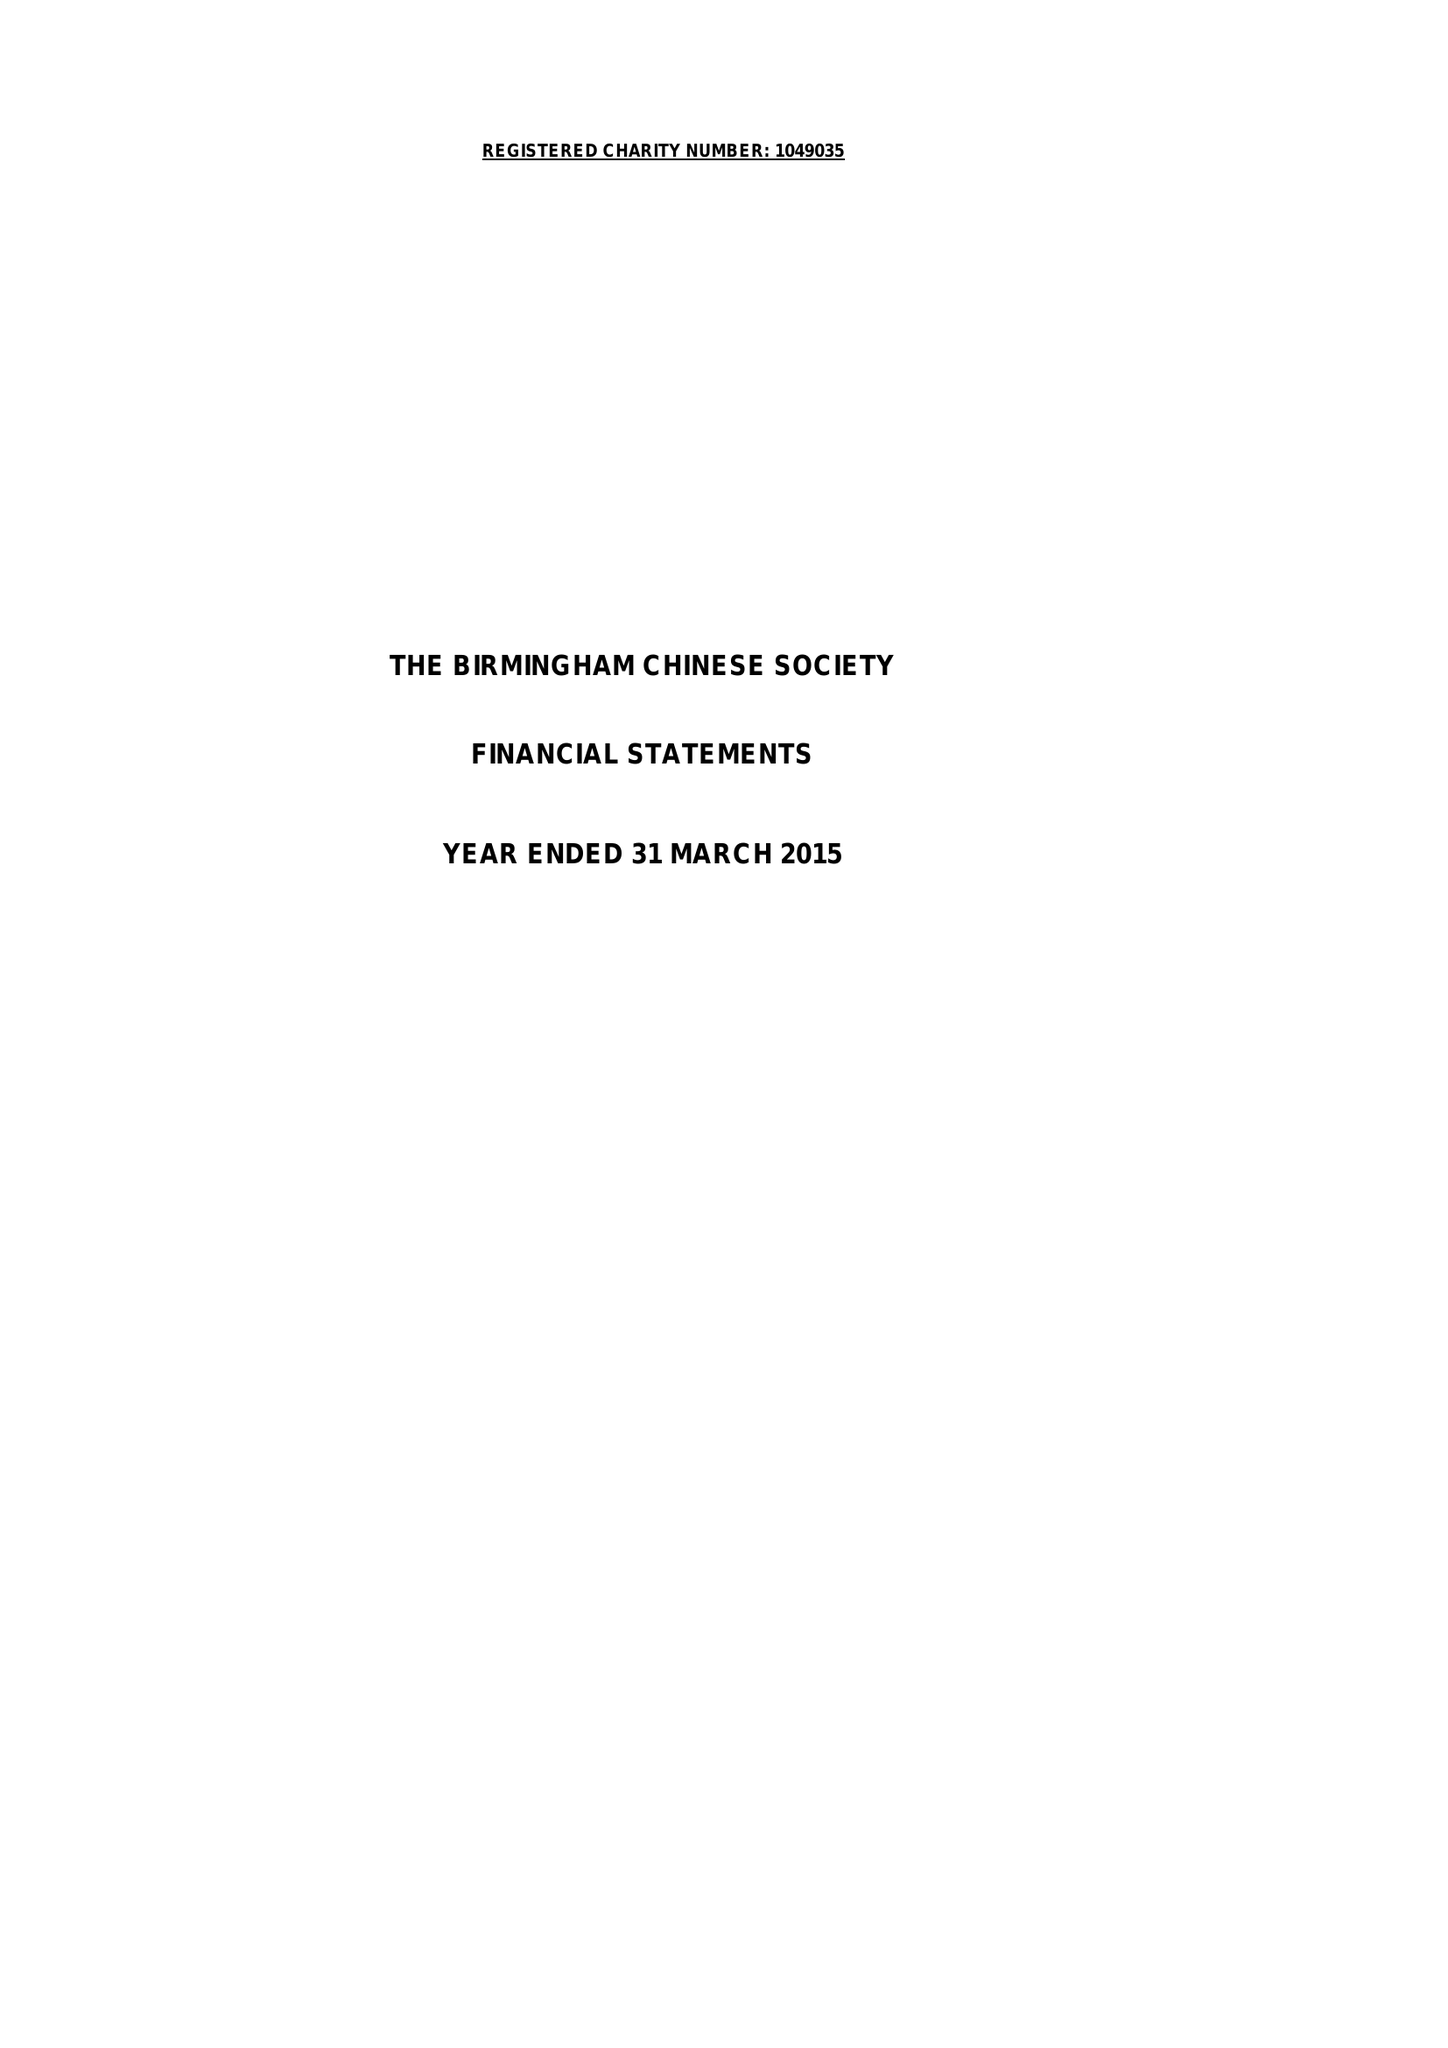What is the value for the income_annually_in_british_pounds?
Answer the question using a single word or phrase. 59989.00 